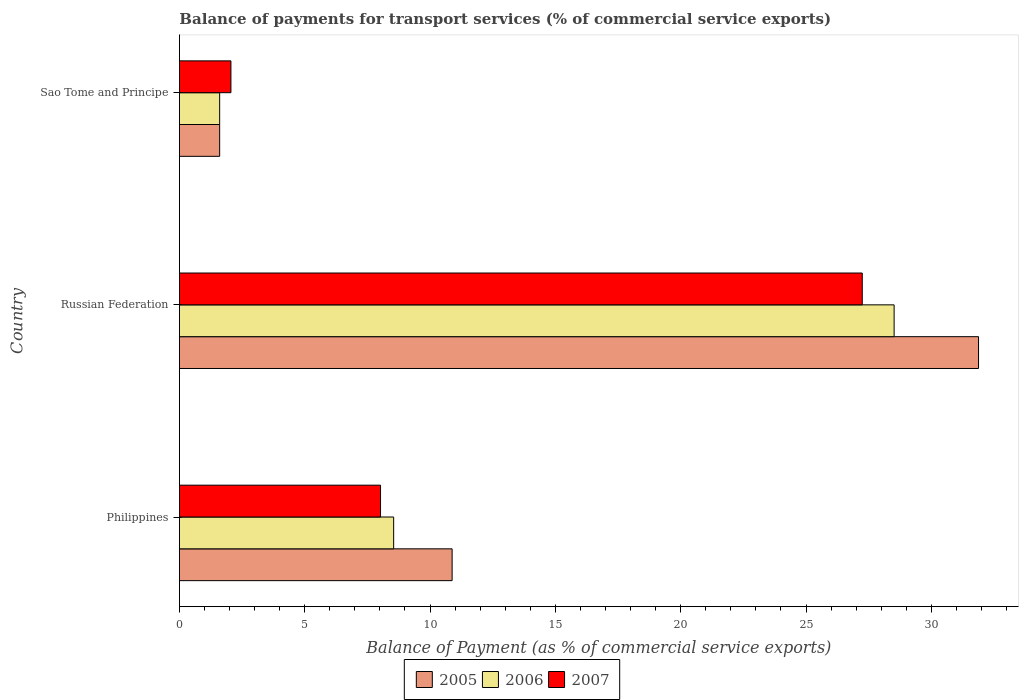How many groups of bars are there?
Your answer should be compact. 3. Are the number of bars on each tick of the Y-axis equal?
Your answer should be very brief. Yes. How many bars are there on the 1st tick from the top?
Your response must be concise. 3. How many bars are there on the 3rd tick from the bottom?
Make the answer very short. 3. What is the label of the 1st group of bars from the top?
Offer a very short reply. Sao Tome and Principe. What is the balance of payments for transport services in 2005 in Philippines?
Ensure brevity in your answer.  10.88. Across all countries, what is the maximum balance of payments for transport services in 2007?
Give a very brief answer. 27.25. Across all countries, what is the minimum balance of payments for transport services in 2007?
Ensure brevity in your answer.  2.05. In which country was the balance of payments for transport services in 2007 maximum?
Give a very brief answer. Russian Federation. In which country was the balance of payments for transport services in 2005 minimum?
Provide a short and direct response. Sao Tome and Principe. What is the total balance of payments for transport services in 2005 in the graph?
Offer a terse response. 44.37. What is the difference between the balance of payments for transport services in 2007 in Russian Federation and that in Sao Tome and Principe?
Provide a succinct answer. 25.19. What is the difference between the balance of payments for transport services in 2007 in Russian Federation and the balance of payments for transport services in 2006 in Sao Tome and Principe?
Give a very brief answer. 25.64. What is the average balance of payments for transport services in 2006 per country?
Provide a short and direct response. 12.89. What is the difference between the balance of payments for transport services in 2006 and balance of payments for transport services in 2007 in Sao Tome and Principe?
Your answer should be very brief. -0.45. What is the ratio of the balance of payments for transport services in 2007 in Philippines to that in Sao Tome and Principe?
Offer a terse response. 3.91. Is the balance of payments for transport services in 2006 in Russian Federation less than that in Sao Tome and Principe?
Your response must be concise. No. What is the difference between the highest and the second highest balance of payments for transport services in 2006?
Offer a very short reply. 19.97. What is the difference between the highest and the lowest balance of payments for transport services in 2007?
Make the answer very short. 25.19. In how many countries, is the balance of payments for transport services in 2007 greater than the average balance of payments for transport services in 2007 taken over all countries?
Ensure brevity in your answer.  1. What does the 1st bar from the top in Sao Tome and Principe represents?
Give a very brief answer. 2007. What does the 1st bar from the bottom in Philippines represents?
Provide a succinct answer. 2005. How many bars are there?
Your answer should be compact. 9. Where does the legend appear in the graph?
Your answer should be very brief. Bottom center. How are the legend labels stacked?
Ensure brevity in your answer.  Horizontal. What is the title of the graph?
Your answer should be compact. Balance of payments for transport services (% of commercial service exports). What is the label or title of the X-axis?
Offer a terse response. Balance of Payment (as % of commercial service exports). What is the Balance of Payment (as % of commercial service exports) in 2005 in Philippines?
Your response must be concise. 10.88. What is the Balance of Payment (as % of commercial service exports) of 2006 in Philippines?
Your answer should be very brief. 8.55. What is the Balance of Payment (as % of commercial service exports) in 2007 in Philippines?
Offer a very short reply. 8.02. What is the Balance of Payment (as % of commercial service exports) of 2005 in Russian Federation?
Keep it short and to the point. 31.88. What is the Balance of Payment (as % of commercial service exports) in 2006 in Russian Federation?
Your answer should be very brief. 28.52. What is the Balance of Payment (as % of commercial service exports) of 2007 in Russian Federation?
Offer a terse response. 27.25. What is the Balance of Payment (as % of commercial service exports) of 2005 in Sao Tome and Principe?
Provide a succinct answer. 1.61. What is the Balance of Payment (as % of commercial service exports) in 2006 in Sao Tome and Principe?
Give a very brief answer. 1.61. What is the Balance of Payment (as % of commercial service exports) of 2007 in Sao Tome and Principe?
Ensure brevity in your answer.  2.05. Across all countries, what is the maximum Balance of Payment (as % of commercial service exports) in 2005?
Your response must be concise. 31.88. Across all countries, what is the maximum Balance of Payment (as % of commercial service exports) in 2006?
Your answer should be very brief. 28.52. Across all countries, what is the maximum Balance of Payment (as % of commercial service exports) of 2007?
Your answer should be compact. 27.25. Across all countries, what is the minimum Balance of Payment (as % of commercial service exports) of 2005?
Your response must be concise. 1.61. Across all countries, what is the minimum Balance of Payment (as % of commercial service exports) in 2006?
Your response must be concise. 1.61. Across all countries, what is the minimum Balance of Payment (as % of commercial service exports) of 2007?
Your response must be concise. 2.05. What is the total Balance of Payment (as % of commercial service exports) in 2005 in the graph?
Offer a very short reply. 44.37. What is the total Balance of Payment (as % of commercial service exports) of 2006 in the graph?
Provide a succinct answer. 38.67. What is the total Balance of Payment (as % of commercial service exports) in 2007 in the graph?
Provide a short and direct response. 37.32. What is the difference between the Balance of Payment (as % of commercial service exports) of 2005 in Philippines and that in Russian Federation?
Provide a short and direct response. -21. What is the difference between the Balance of Payment (as % of commercial service exports) of 2006 in Philippines and that in Russian Federation?
Your answer should be compact. -19.97. What is the difference between the Balance of Payment (as % of commercial service exports) in 2007 in Philippines and that in Russian Federation?
Make the answer very short. -19.22. What is the difference between the Balance of Payment (as % of commercial service exports) of 2005 in Philippines and that in Sao Tome and Principe?
Your answer should be compact. 9.28. What is the difference between the Balance of Payment (as % of commercial service exports) of 2006 in Philippines and that in Sao Tome and Principe?
Make the answer very short. 6.94. What is the difference between the Balance of Payment (as % of commercial service exports) in 2007 in Philippines and that in Sao Tome and Principe?
Your answer should be compact. 5.97. What is the difference between the Balance of Payment (as % of commercial service exports) of 2005 in Russian Federation and that in Sao Tome and Principe?
Provide a succinct answer. 30.28. What is the difference between the Balance of Payment (as % of commercial service exports) in 2006 in Russian Federation and that in Sao Tome and Principe?
Your response must be concise. 26.91. What is the difference between the Balance of Payment (as % of commercial service exports) of 2007 in Russian Federation and that in Sao Tome and Principe?
Provide a succinct answer. 25.19. What is the difference between the Balance of Payment (as % of commercial service exports) in 2005 in Philippines and the Balance of Payment (as % of commercial service exports) in 2006 in Russian Federation?
Make the answer very short. -17.64. What is the difference between the Balance of Payment (as % of commercial service exports) in 2005 in Philippines and the Balance of Payment (as % of commercial service exports) in 2007 in Russian Federation?
Make the answer very short. -16.36. What is the difference between the Balance of Payment (as % of commercial service exports) in 2006 in Philippines and the Balance of Payment (as % of commercial service exports) in 2007 in Russian Federation?
Offer a very short reply. -18.7. What is the difference between the Balance of Payment (as % of commercial service exports) of 2005 in Philippines and the Balance of Payment (as % of commercial service exports) of 2006 in Sao Tome and Principe?
Offer a terse response. 9.28. What is the difference between the Balance of Payment (as % of commercial service exports) of 2005 in Philippines and the Balance of Payment (as % of commercial service exports) of 2007 in Sao Tome and Principe?
Your answer should be compact. 8.83. What is the difference between the Balance of Payment (as % of commercial service exports) of 2006 in Philippines and the Balance of Payment (as % of commercial service exports) of 2007 in Sao Tome and Principe?
Offer a very short reply. 6.49. What is the difference between the Balance of Payment (as % of commercial service exports) in 2005 in Russian Federation and the Balance of Payment (as % of commercial service exports) in 2006 in Sao Tome and Principe?
Provide a succinct answer. 30.28. What is the difference between the Balance of Payment (as % of commercial service exports) of 2005 in Russian Federation and the Balance of Payment (as % of commercial service exports) of 2007 in Sao Tome and Principe?
Keep it short and to the point. 29.83. What is the difference between the Balance of Payment (as % of commercial service exports) of 2006 in Russian Federation and the Balance of Payment (as % of commercial service exports) of 2007 in Sao Tome and Principe?
Provide a short and direct response. 26.46. What is the average Balance of Payment (as % of commercial service exports) in 2005 per country?
Your answer should be very brief. 14.79. What is the average Balance of Payment (as % of commercial service exports) in 2006 per country?
Provide a succinct answer. 12.89. What is the average Balance of Payment (as % of commercial service exports) of 2007 per country?
Give a very brief answer. 12.44. What is the difference between the Balance of Payment (as % of commercial service exports) of 2005 and Balance of Payment (as % of commercial service exports) of 2006 in Philippines?
Your answer should be compact. 2.33. What is the difference between the Balance of Payment (as % of commercial service exports) in 2005 and Balance of Payment (as % of commercial service exports) in 2007 in Philippines?
Your answer should be compact. 2.86. What is the difference between the Balance of Payment (as % of commercial service exports) of 2006 and Balance of Payment (as % of commercial service exports) of 2007 in Philippines?
Your answer should be compact. 0.52. What is the difference between the Balance of Payment (as % of commercial service exports) of 2005 and Balance of Payment (as % of commercial service exports) of 2006 in Russian Federation?
Make the answer very short. 3.37. What is the difference between the Balance of Payment (as % of commercial service exports) in 2005 and Balance of Payment (as % of commercial service exports) in 2007 in Russian Federation?
Provide a succinct answer. 4.64. What is the difference between the Balance of Payment (as % of commercial service exports) of 2006 and Balance of Payment (as % of commercial service exports) of 2007 in Russian Federation?
Your answer should be compact. 1.27. What is the difference between the Balance of Payment (as % of commercial service exports) in 2005 and Balance of Payment (as % of commercial service exports) in 2007 in Sao Tome and Principe?
Provide a succinct answer. -0.45. What is the difference between the Balance of Payment (as % of commercial service exports) in 2006 and Balance of Payment (as % of commercial service exports) in 2007 in Sao Tome and Principe?
Provide a succinct answer. -0.45. What is the ratio of the Balance of Payment (as % of commercial service exports) in 2005 in Philippines to that in Russian Federation?
Your answer should be compact. 0.34. What is the ratio of the Balance of Payment (as % of commercial service exports) of 2006 in Philippines to that in Russian Federation?
Keep it short and to the point. 0.3. What is the ratio of the Balance of Payment (as % of commercial service exports) of 2007 in Philippines to that in Russian Federation?
Make the answer very short. 0.29. What is the ratio of the Balance of Payment (as % of commercial service exports) in 2005 in Philippines to that in Sao Tome and Principe?
Provide a short and direct response. 6.78. What is the ratio of the Balance of Payment (as % of commercial service exports) of 2006 in Philippines to that in Sao Tome and Principe?
Your answer should be very brief. 5.32. What is the ratio of the Balance of Payment (as % of commercial service exports) in 2007 in Philippines to that in Sao Tome and Principe?
Ensure brevity in your answer.  3.91. What is the ratio of the Balance of Payment (as % of commercial service exports) in 2005 in Russian Federation to that in Sao Tome and Principe?
Offer a terse response. 19.86. What is the ratio of the Balance of Payment (as % of commercial service exports) in 2006 in Russian Federation to that in Sao Tome and Principe?
Ensure brevity in your answer.  17.76. What is the ratio of the Balance of Payment (as % of commercial service exports) of 2007 in Russian Federation to that in Sao Tome and Principe?
Provide a short and direct response. 13.26. What is the difference between the highest and the second highest Balance of Payment (as % of commercial service exports) in 2005?
Give a very brief answer. 21. What is the difference between the highest and the second highest Balance of Payment (as % of commercial service exports) of 2006?
Ensure brevity in your answer.  19.97. What is the difference between the highest and the second highest Balance of Payment (as % of commercial service exports) of 2007?
Make the answer very short. 19.22. What is the difference between the highest and the lowest Balance of Payment (as % of commercial service exports) in 2005?
Your answer should be compact. 30.28. What is the difference between the highest and the lowest Balance of Payment (as % of commercial service exports) of 2006?
Make the answer very short. 26.91. What is the difference between the highest and the lowest Balance of Payment (as % of commercial service exports) in 2007?
Offer a very short reply. 25.19. 